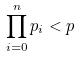Convert formula to latex. <formula><loc_0><loc_0><loc_500><loc_500>\prod _ { i = 0 } ^ { n } p _ { i } < p</formula> 